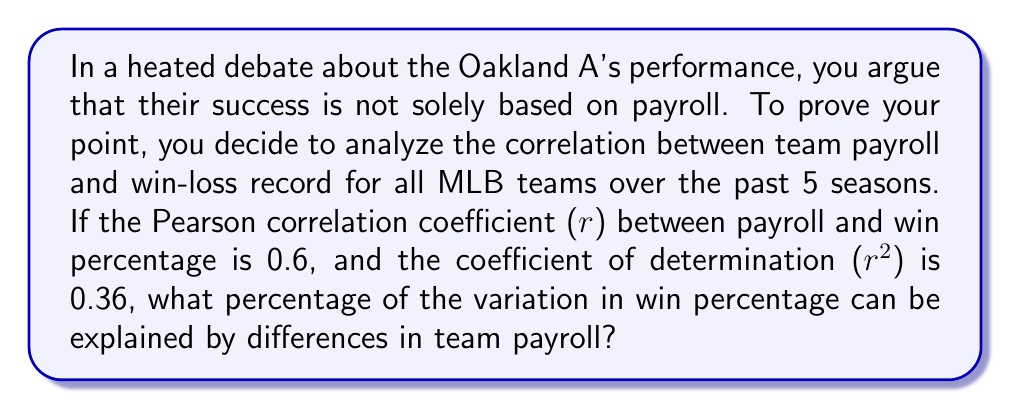Teach me how to tackle this problem. To solve this problem, we need to understand the relationship between the Pearson correlation coefficient (r) and the coefficient of determination ($r^2$).

1. We are given that r = 0.6 and $r^2$ = 0.36.

2. The coefficient of determination ($r^2$) represents the proportion of the variance in the dependent variable (win percentage) that is predictable from the independent variable (team payroll).

3. To express this as a percentage, we simply multiply $r^2$ by 100:

   Percentage = $r^2 \times 100\%$
   
   Percentage = $0.36 \times 100\%$ = 36%

4. This means that 36% of the variation in win percentage can be explained by differences in team payroll.

5. It's important to note that while there is a moderate positive correlation between payroll and win percentage, the majority of the variation (64%) is explained by other factors, supporting your argument that the Oakland A's success is not solely based on payroll.
Answer: 36% 